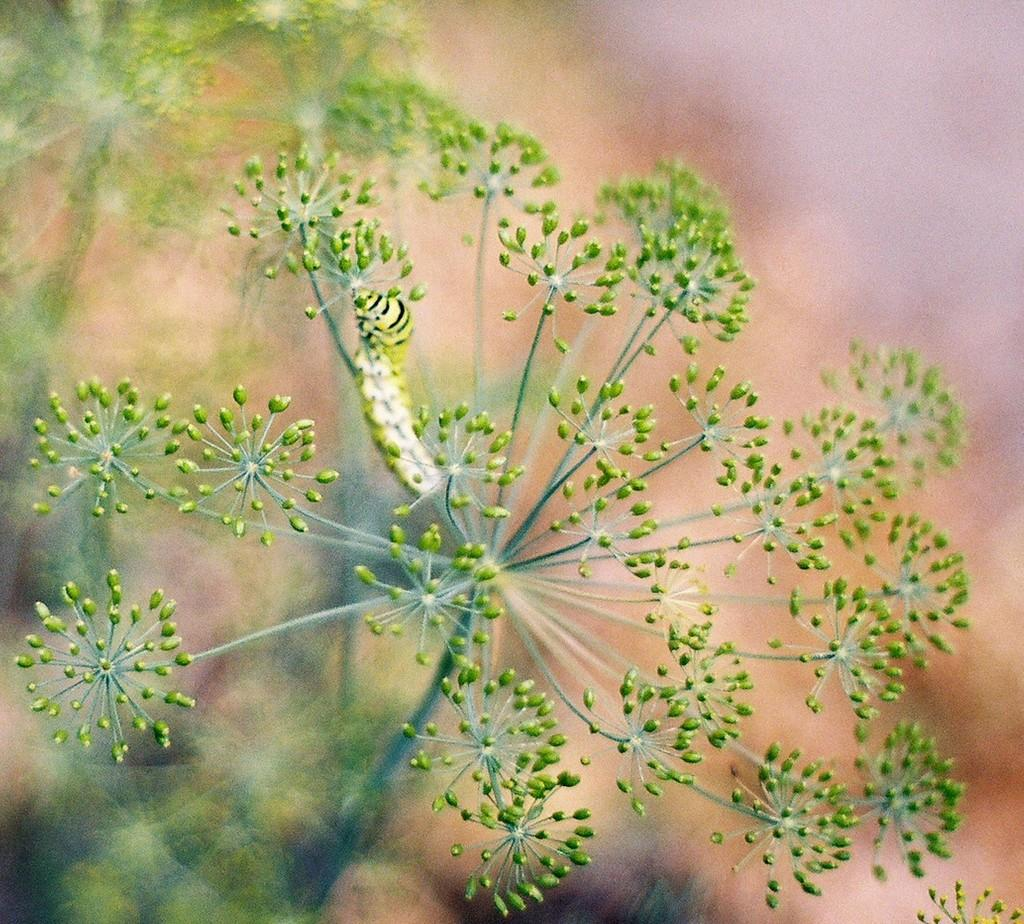What is the main subject of the image? The main subject of the image is a plant. Can you describe the plant in the image? The image is a zoomed-in picture of a plant. Is there anything else visible in the image besides the plant? Yes, there is an insect sitting on the stem of the plant in the image. What type of cemetery can be seen in the background of the image? There is no cemetery present in the image; it is a close-up of a plant with an insect on its stem. How does the insect affect the plant's ability to sleep in the image? The image does not depict the plant sleeping, nor does it show any interaction between the insect and the plant that would suggest an impact on the plant's sleep. 